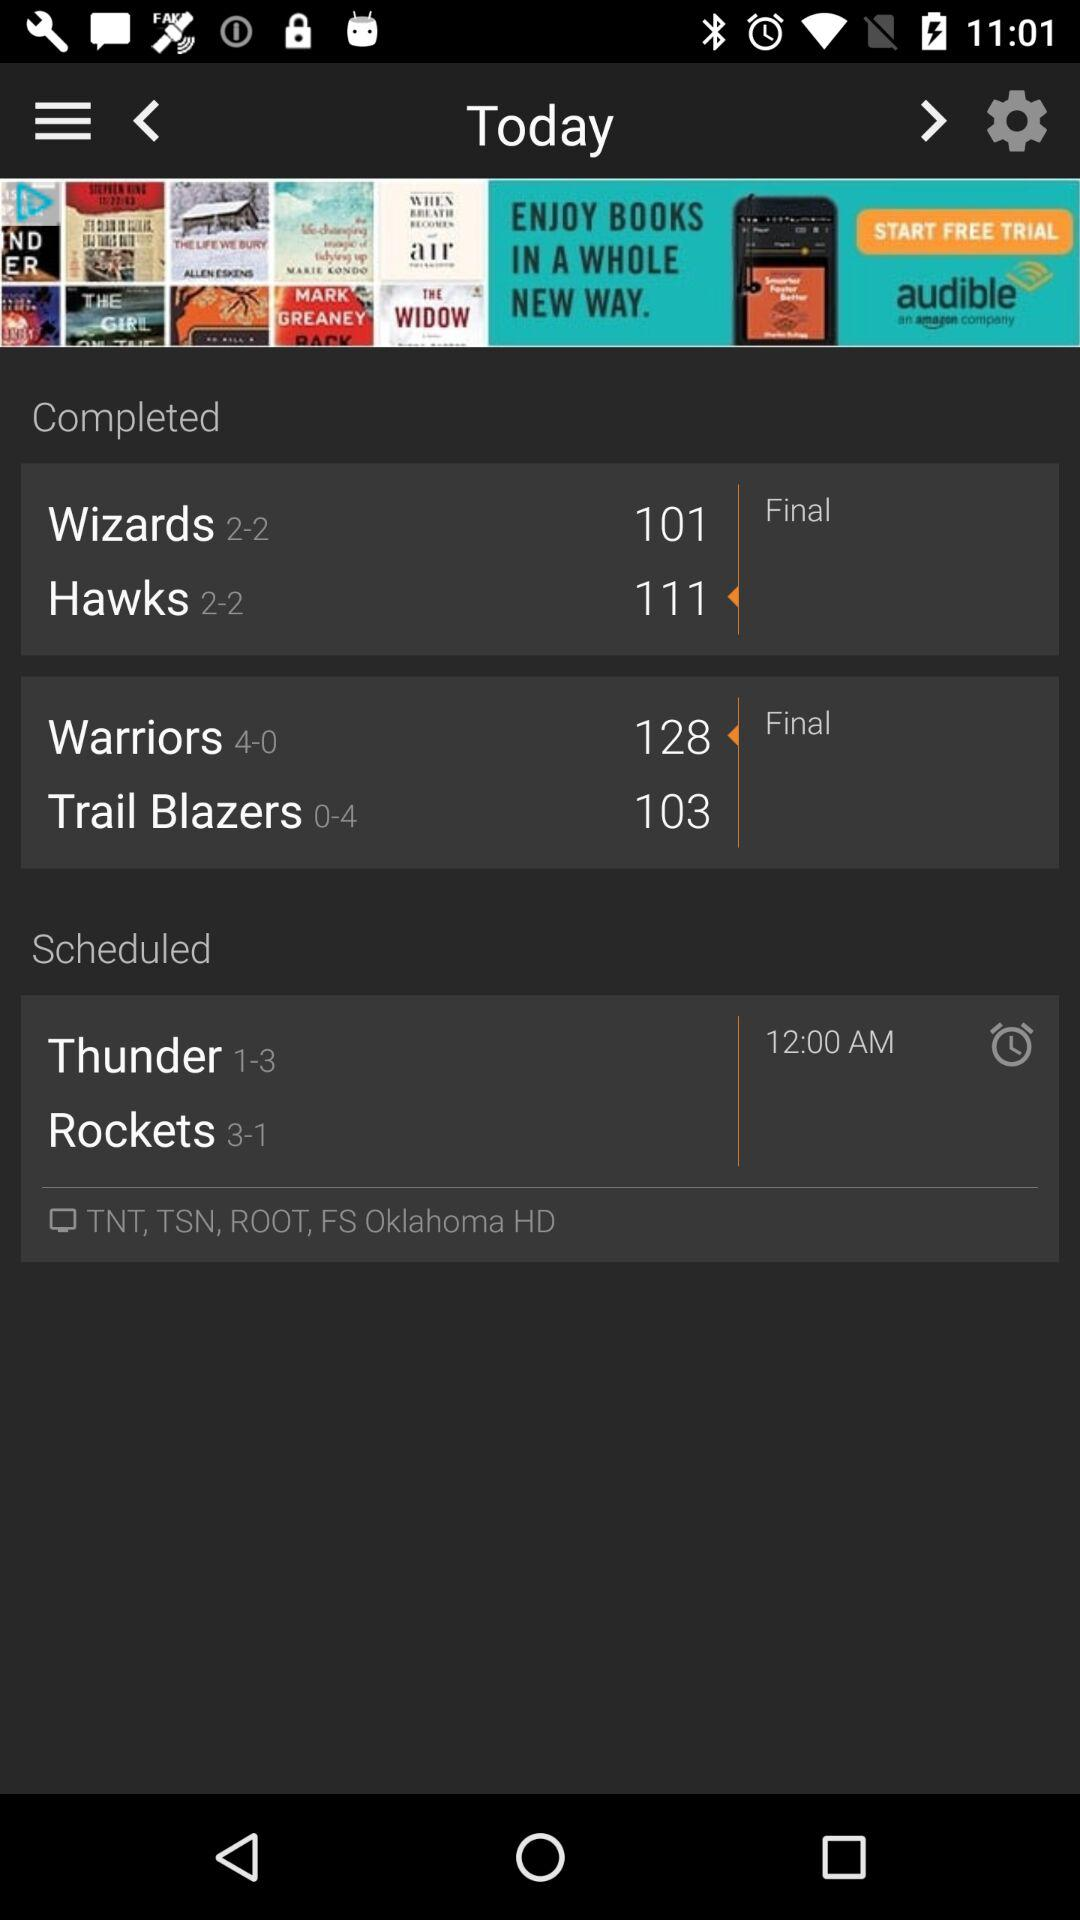Which team has the best record in the Completed section?
Answer the question using a single word or phrase. Warriors 